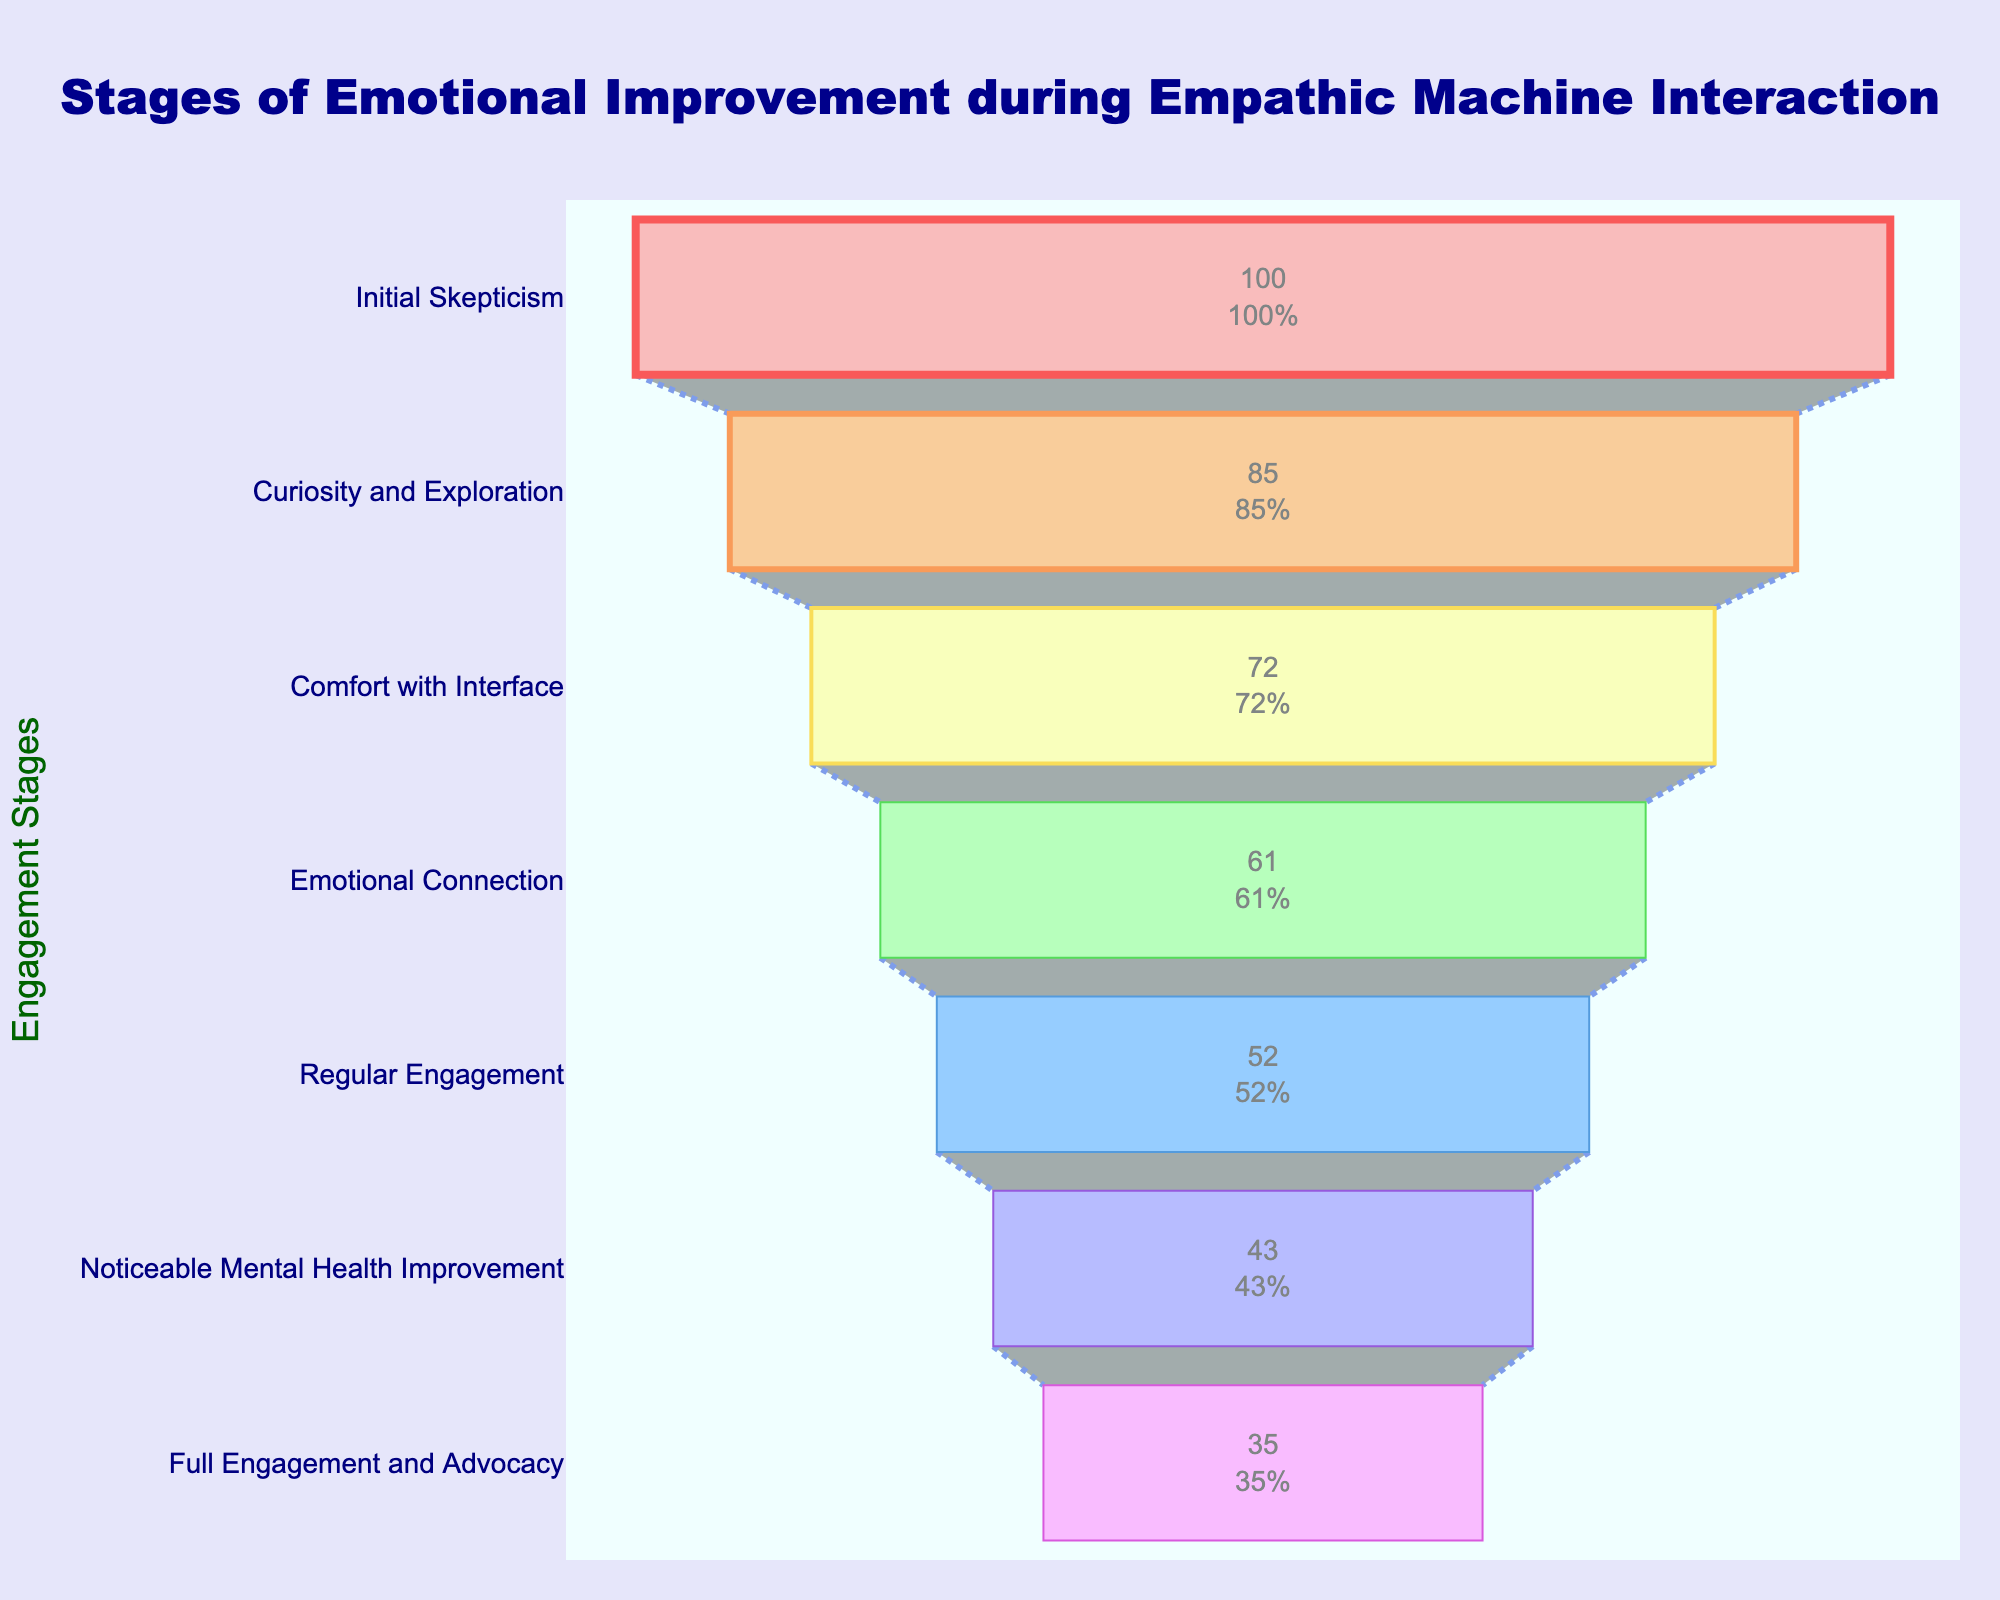What is the title of the plot? The title is explicitly mentioned at the top of the plot.
Answer: Stages of Emotional Improvement during Empathic Machine Interaction How many stages are there in the plot? Count the number of stages listed on the y-axis.
Answer: 7 Which stage has the most participants? Identify the bar on the funnel chart that is the widest.
Answer: Initial Skepticism What is the second stage in the funnel? Look at the sequence of stages listed on the y-axis; the second one is the answer.
Answer: Curiosity and Exploration What percentage of initial participants reach full engagement and advocacy? Identify the participants at the Initial Skepticism stage (100) and those at Full Engagement and Advocacy stage (35). The percentage is (35/100)*100.
Answer: 35% How many more participants are there at the Emotional Connection stage compared to the Regular Engagement stage? Subtract the number of participants at Regular Engagement (52) from the number at Emotional Connection (61).
Answer: 9 more participants What stage comes immediately before 'Noticeable Mental Health Improvement'? Look at the sequence of the stages on the y-axis; the one right before Noticeable Mental Health Improvement is the stage before.
Answer: Regular Engagement What is the difference in participant numbers between the stage with the fewest participants and the stage with the most participants? Subtract the number of participants at Full Engagement and Advocacy (35, the fewest) from Initial Skepticism (100, the most).
Answer: 65 Which stage shows the first noticeable decrease in participant numbers by more than 10? Compare the difference in participant numbers between consecutive stages; look for the first instance where the decrease is more than 10.
Answer: Initial Skepticism to Curiosity and Exploration (difference of 15) Do more participants feel an emotional connection or have noticed mental health improvement? Compare the number of participants at Emotional Connection (61) to those at Noticeable Mental Health Improvement (43).
Answer: Emotional Connection 